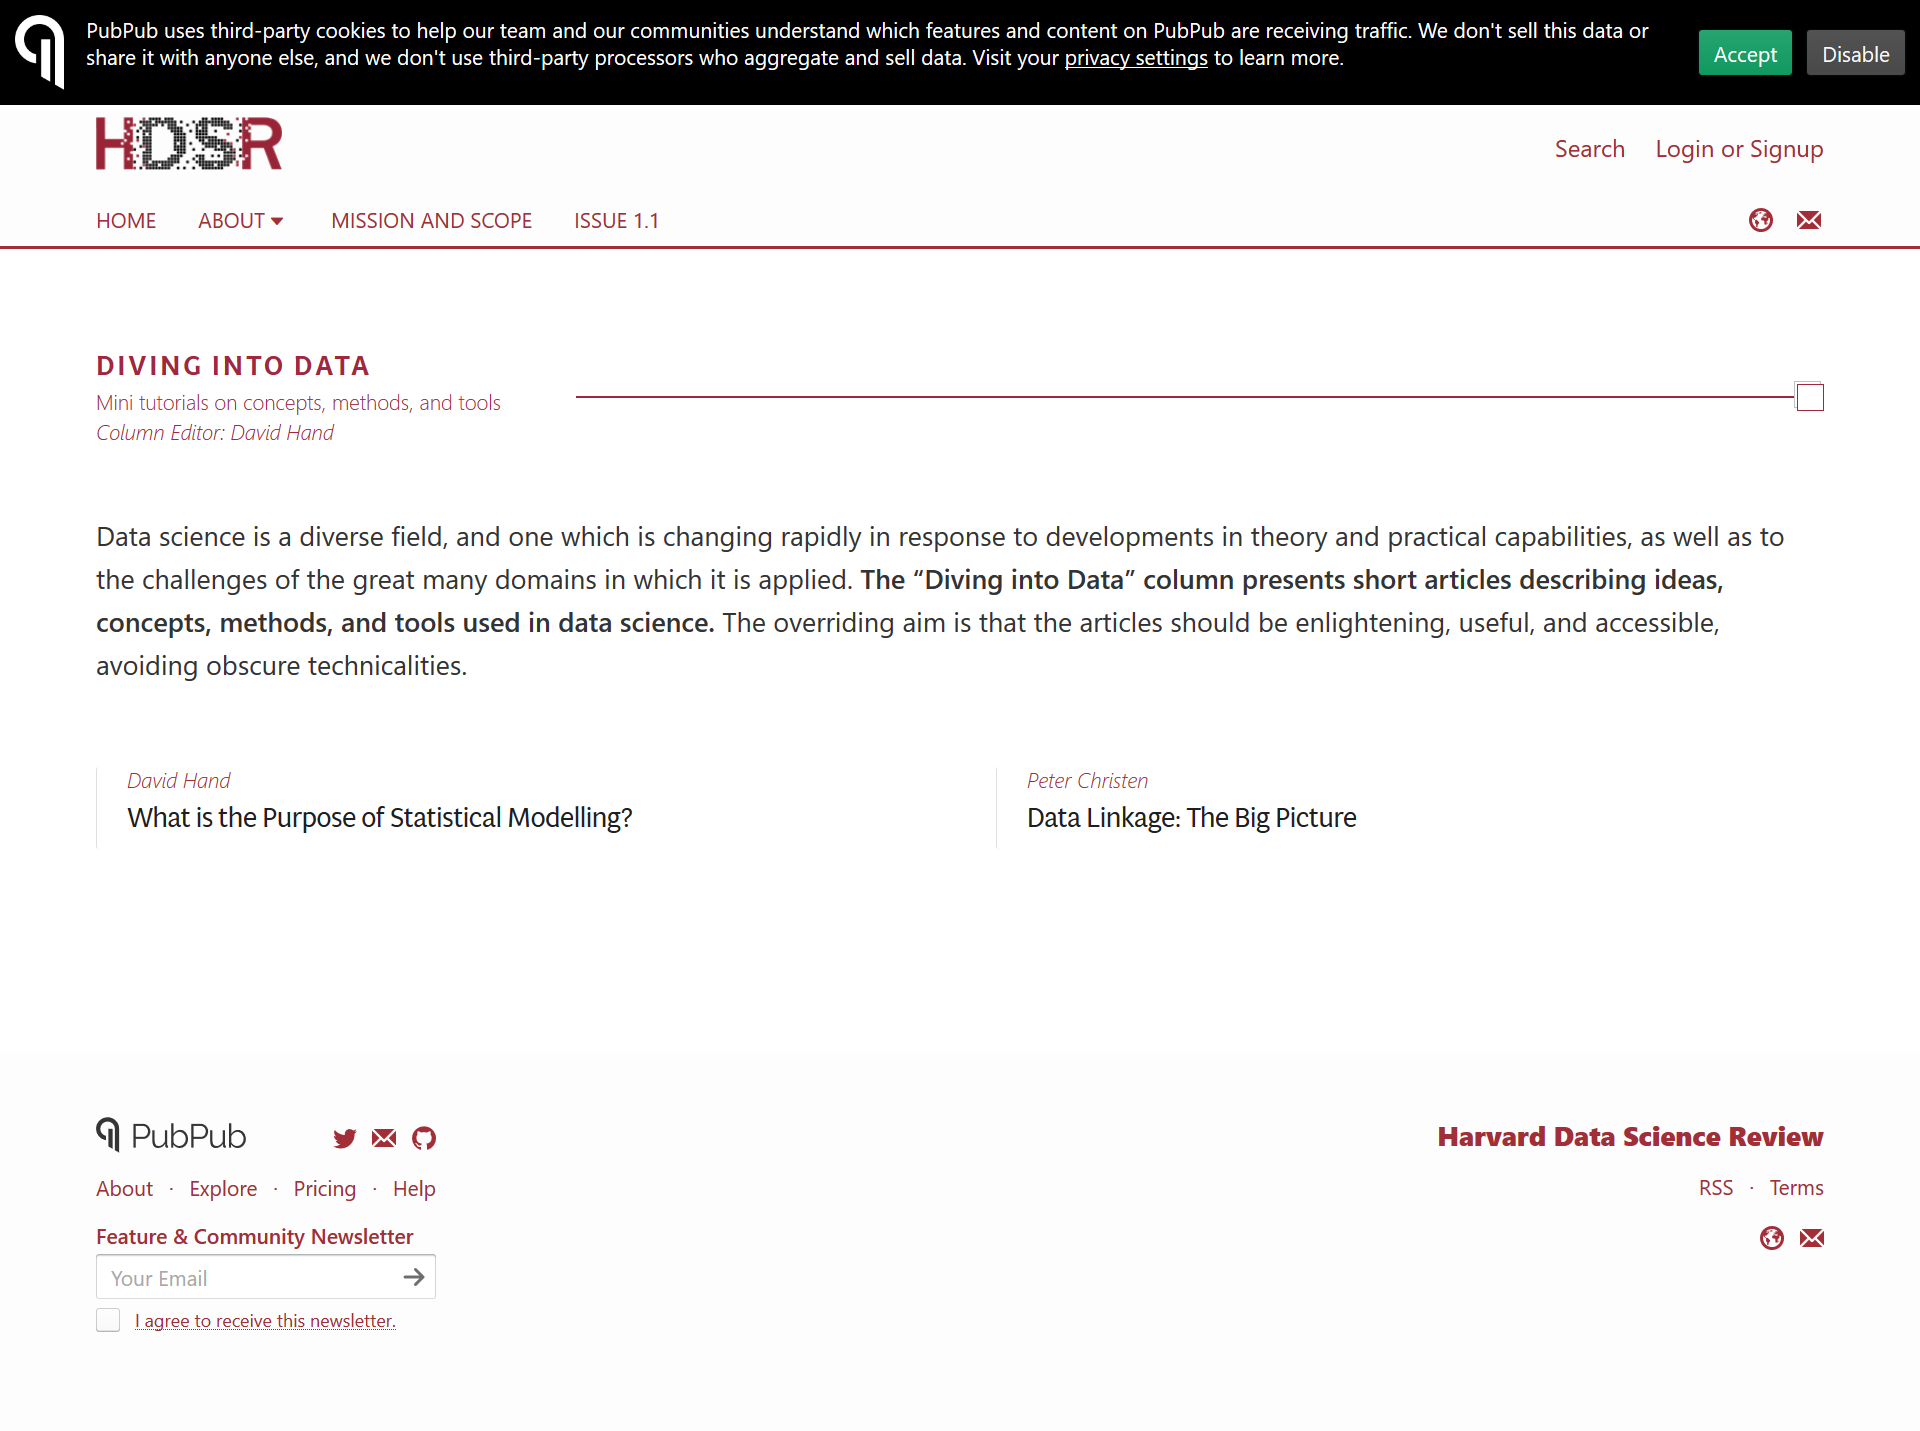List a handful of essential elements in this visual. The article titled "Data Linkage: The Big Picture" was written by Peter Christen. The article on diving into data is edited by David Hand. Data science is a diverse field that is becoming increasingly popular. 